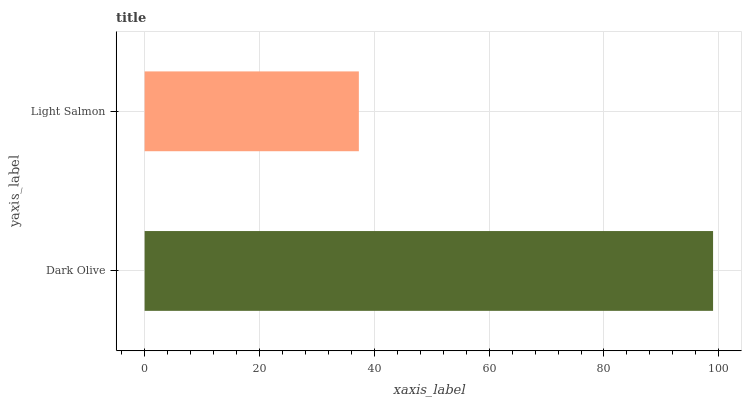Is Light Salmon the minimum?
Answer yes or no. Yes. Is Dark Olive the maximum?
Answer yes or no. Yes. Is Light Salmon the maximum?
Answer yes or no. No. Is Dark Olive greater than Light Salmon?
Answer yes or no. Yes. Is Light Salmon less than Dark Olive?
Answer yes or no. Yes. Is Light Salmon greater than Dark Olive?
Answer yes or no. No. Is Dark Olive less than Light Salmon?
Answer yes or no. No. Is Dark Olive the high median?
Answer yes or no. Yes. Is Light Salmon the low median?
Answer yes or no. Yes. Is Light Salmon the high median?
Answer yes or no. No. Is Dark Olive the low median?
Answer yes or no. No. 